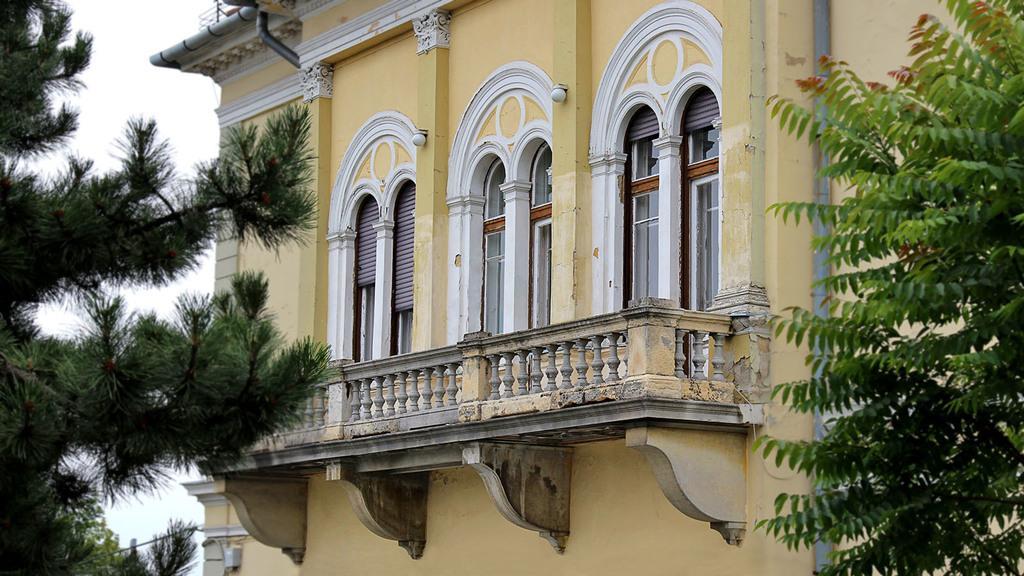Could you give a brief overview of what you see in this image? In this image, we can see a building with a few windows. There are a few trees. We can also see some objects attached to the wall of the building. We can also see the sky and a wire. 